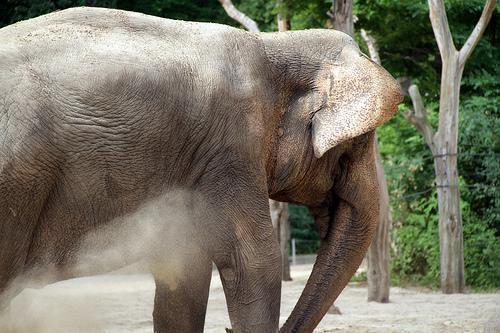How many elephants are there?
Give a very brief answer. 1. 